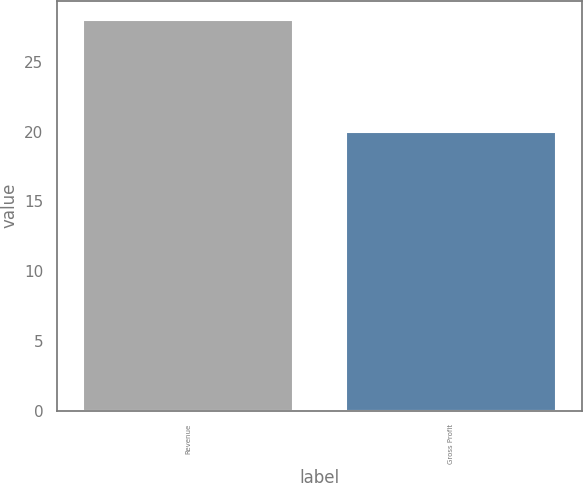Convert chart to OTSL. <chart><loc_0><loc_0><loc_500><loc_500><bar_chart><fcel>Revenue<fcel>Gross Profit<nl><fcel>28<fcel>20<nl></chart> 